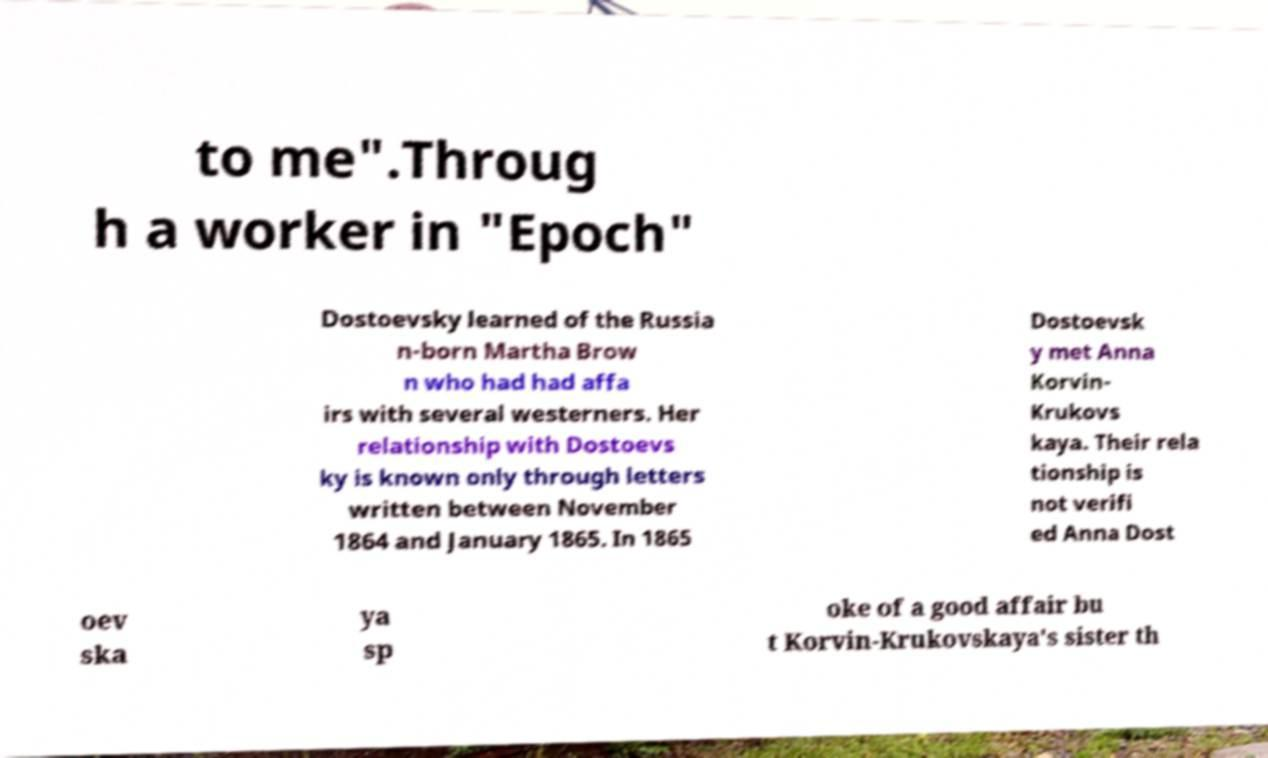Please read and relay the text visible in this image. What does it say? to me".Throug h a worker in "Epoch" Dostoevsky learned of the Russia n-born Martha Brow n who had had affa irs with several westerners. Her relationship with Dostoevs ky is known only through letters written between November 1864 and January 1865. In 1865 Dostoevsk y met Anna Korvin- Krukovs kaya. Their rela tionship is not verifi ed Anna Dost oev ska ya sp oke of a good affair bu t Korvin-Krukovskaya's sister th 